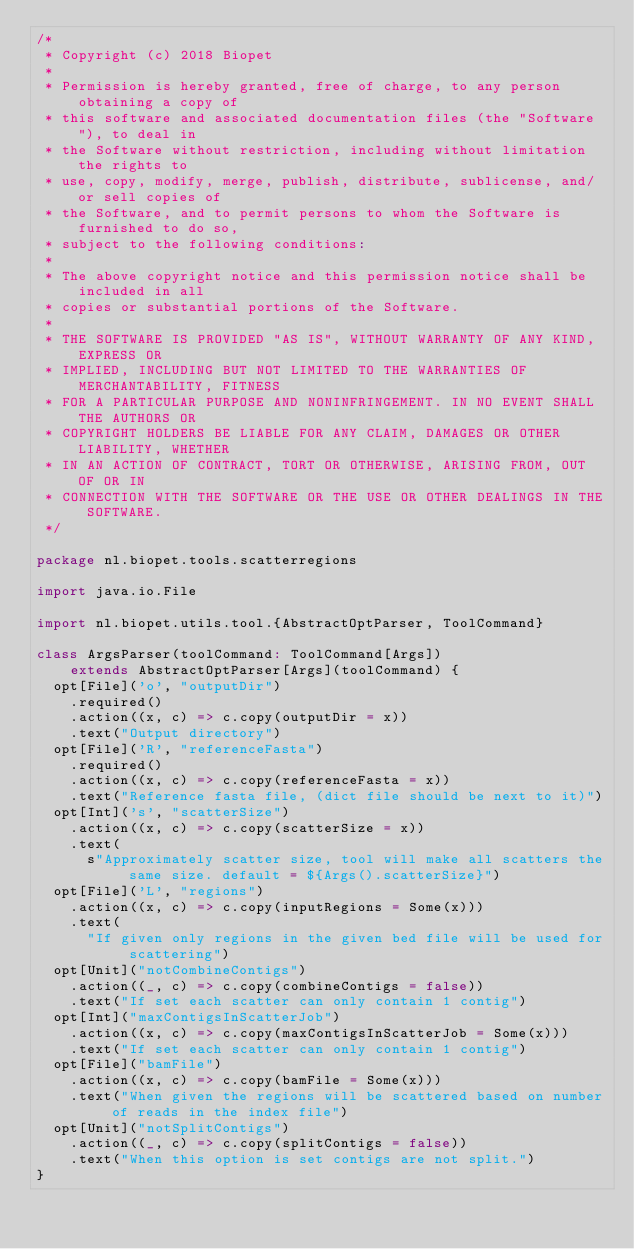Convert code to text. <code><loc_0><loc_0><loc_500><loc_500><_Scala_>/*
 * Copyright (c) 2018 Biopet
 *
 * Permission is hereby granted, free of charge, to any person obtaining a copy of
 * this software and associated documentation files (the "Software"), to deal in
 * the Software without restriction, including without limitation the rights to
 * use, copy, modify, merge, publish, distribute, sublicense, and/or sell copies of
 * the Software, and to permit persons to whom the Software is furnished to do so,
 * subject to the following conditions:
 *
 * The above copyright notice and this permission notice shall be included in all
 * copies or substantial portions of the Software.
 *
 * THE SOFTWARE IS PROVIDED "AS IS", WITHOUT WARRANTY OF ANY KIND, EXPRESS OR
 * IMPLIED, INCLUDING BUT NOT LIMITED TO THE WARRANTIES OF MERCHANTABILITY, FITNESS
 * FOR A PARTICULAR PURPOSE AND NONINFRINGEMENT. IN NO EVENT SHALL THE AUTHORS OR
 * COPYRIGHT HOLDERS BE LIABLE FOR ANY CLAIM, DAMAGES OR OTHER LIABILITY, WHETHER
 * IN AN ACTION OF CONTRACT, TORT OR OTHERWISE, ARISING FROM, OUT OF OR IN
 * CONNECTION WITH THE SOFTWARE OR THE USE OR OTHER DEALINGS IN THE SOFTWARE.
 */

package nl.biopet.tools.scatterregions

import java.io.File

import nl.biopet.utils.tool.{AbstractOptParser, ToolCommand}

class ArgsParser(toolCommand: ToolCommand[Args])
    extends AbstractOptParser[Args](toolCommand) {
  opt[File]('o', "outputDir")
    .required()
    .action((x, c) => c.copy(outputDir = x))
    .text("Output directory")
  opt[File]('R', "referenceFasta")
    .required()
    .action((x, c) => c.copy(referenceFasta = x))
    .text("Reference fasta file, (dict file should be next to it)")
  opt[Int]('s', "scatterSize")
    .action((x, c) => c.copy(scatterSize = x))
    .text(
      s"Approximately scatter size, tool will make all scatters the same size. default = ${Args().scatterSize}")
  opt[File]('L', "regions")
    .action((x, c) => c.copy(inputRegions = Some(x)))
    .text(
      "If given only regions in the given bed file will be used for scattering")
  opt[Unit]("notCombineContigs")
    .action((_, c) => c.copy(combineContigs = false))
    .text("If set each scatter can only contain 1 contig")
  opt[Int]("maxContigsInScatterJob")
    .action((x, c) => c.copy(maxContigsInScatterJob = Some(x)))
    .text("If set each scatter can only contain 1 contig")
  opt[File]("bamFile")
    .action((x, c) => c.copy(bamFile = Some(x)))
    .text("When given the regions will be scattered based on number of reads in the index file")
  opt[Unit]("notSplitContigs")
    .action((_, c) => c.copy(splitContigs = false))
    .text("When this option is set contigs are not split.")
}
</code> 